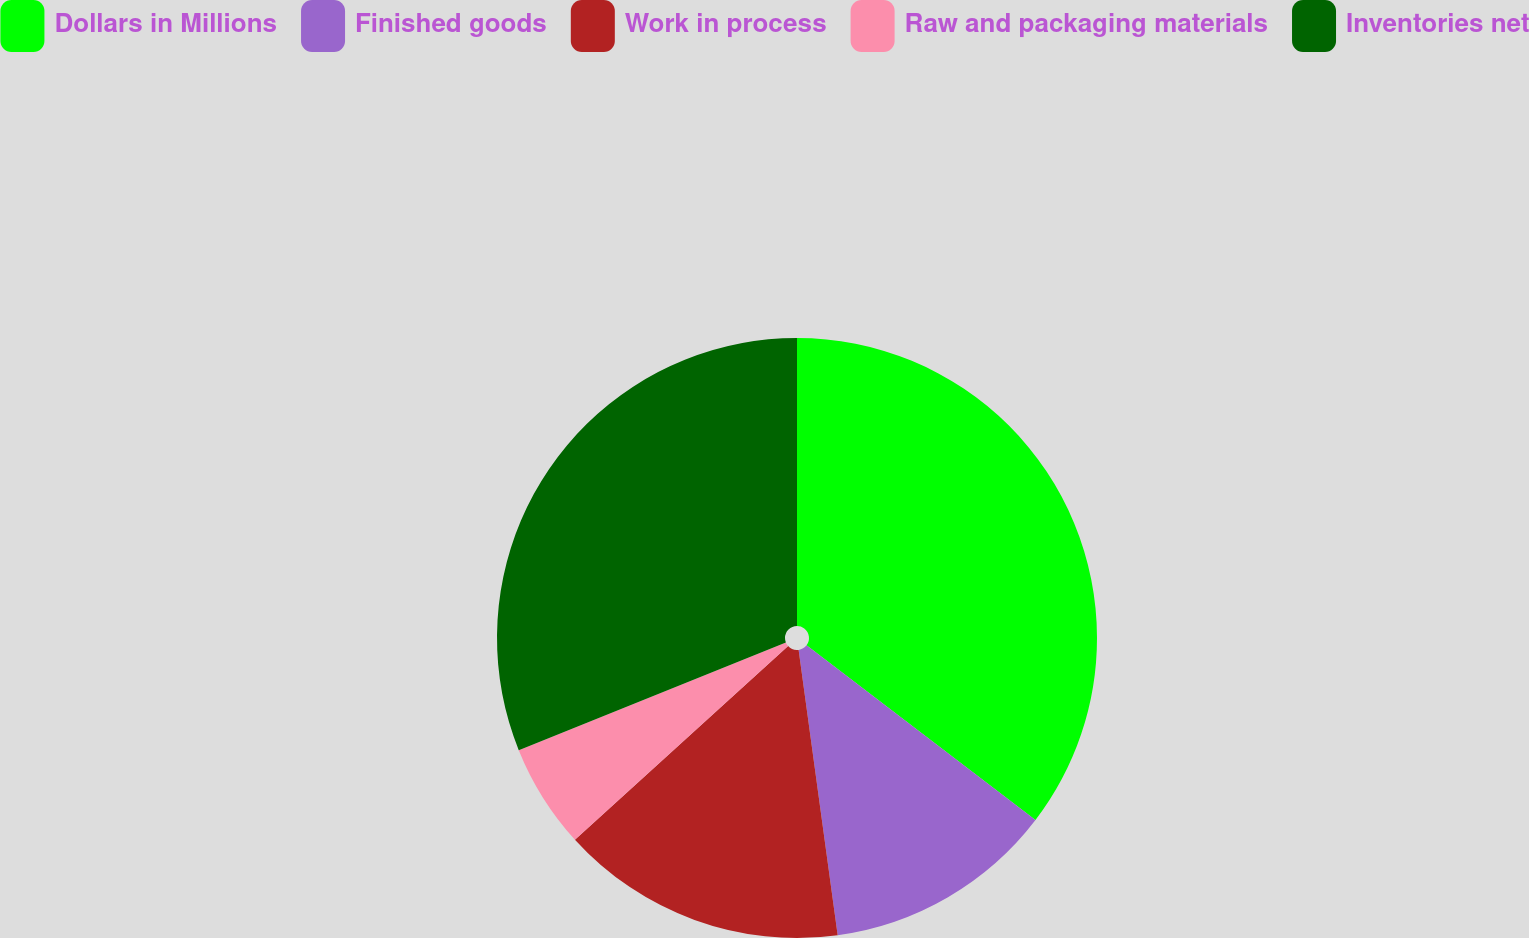Convert chart to OTSL. <chart><loc_0><loc_0><loc_500><loc_500><pie_chart><fcel>Dollars in Millions<fcel>Finished goods<fcel>Work in process<fcel>Raw and packaging materials<fcel>Inventories net<nl><fcel>35.38%<fcel>12.46%<fcel>15.43%<fcel>5.64%<fcel>31.1%<nl></chart> 